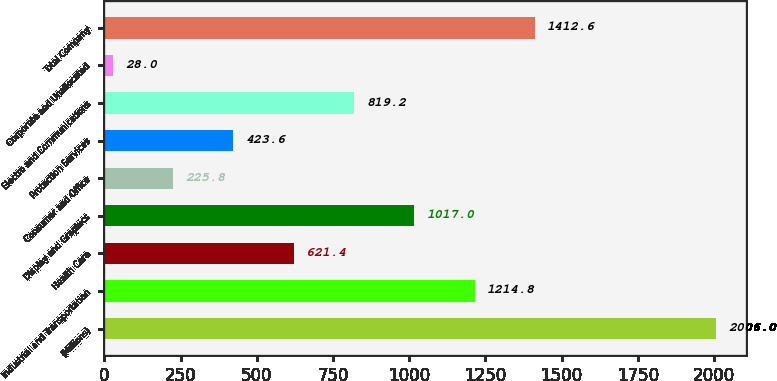Convert chart to OTSL. <chart><loc_0><loc_0><loc_500><loc_500><bar_chart><fcel>(Millions)<fcel>Industrial and Transportation<fcel>Health Care<fcel>Display and Graphics<fcel>Consumer and Office<fcel>Protection Services<fcel>Electro and Communications<fcel>Corporate and Unallocated<fcel>Total Company<nl><fcel>2006<fcel>1214.8<fcel>621.4<fcel>1017<fcel>225.8<fcel>423.6<fcel>819.2<fcel>28<fcel>1412.6<nl></chart> 